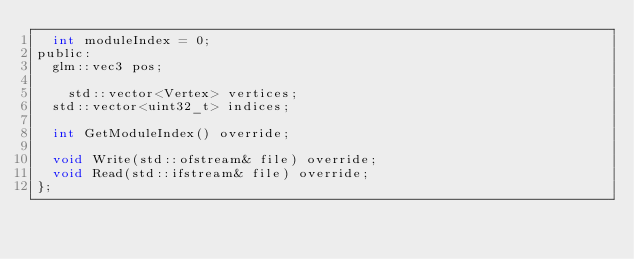Convert code to text. <code><loc_0><loc_0><loc_500><loc_500><_C_>	int moduleIndex = 0;
public:
	glm::vec3 pos;

    std::vector<Vertex> vertices;
	std::vector<uint32_t> indices;

	int GetModuleIndex() override;

	void Write(std::ofstream& file) override;
	void Read(std::ifstream& file) override;
};</code> 